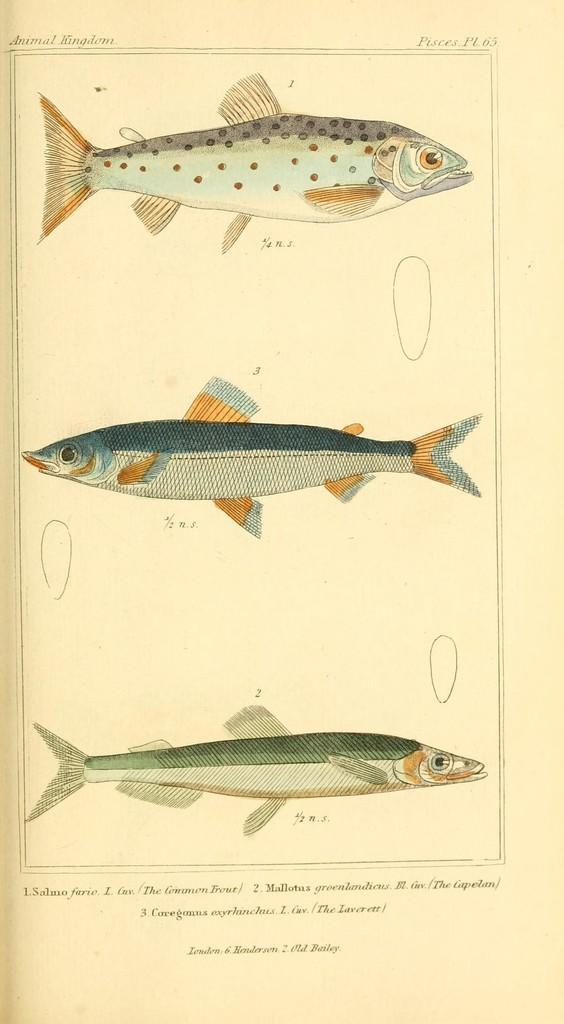Can you describe this image briefly? On this page we can see diagram of fishes. Something written on this page. 